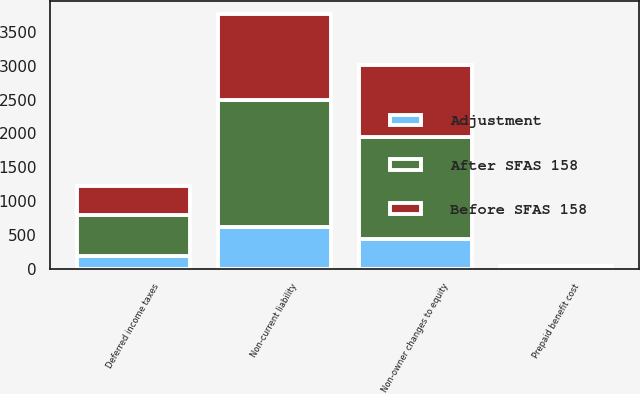Convert chart to OTSL. <chart><loc_0><loc_0><loc_500><loc_500><stacked_bar_chart><ecel><fcel>Prepaid benefit cost<fcel>Non-current liability<fcel>Deferred income taxes<fcel>Non-owner changes to equity<nl><fcel>Before SFAS 158<fcel>20<fcel>1267<fcel>416<fcel>1063<nl><fcel>Adjustment<fcel>7<fcel>615<fcel>192<fcel>440<nl><fcel>After SFAS 158<fcel>13<fcel>1882<fcel>608<fcel>1503<nl></chart> 